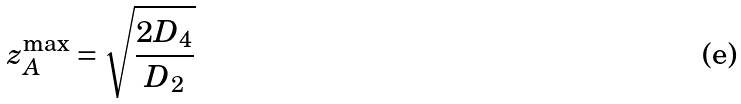Convert formula to latex. <formula><loc_0><loc_0><loc_500><loc_500>z _ { A } ^ { \max } = \sqrt { \frac { 2 D _ { 4 } } { D _ { 2 } } }</formula> 